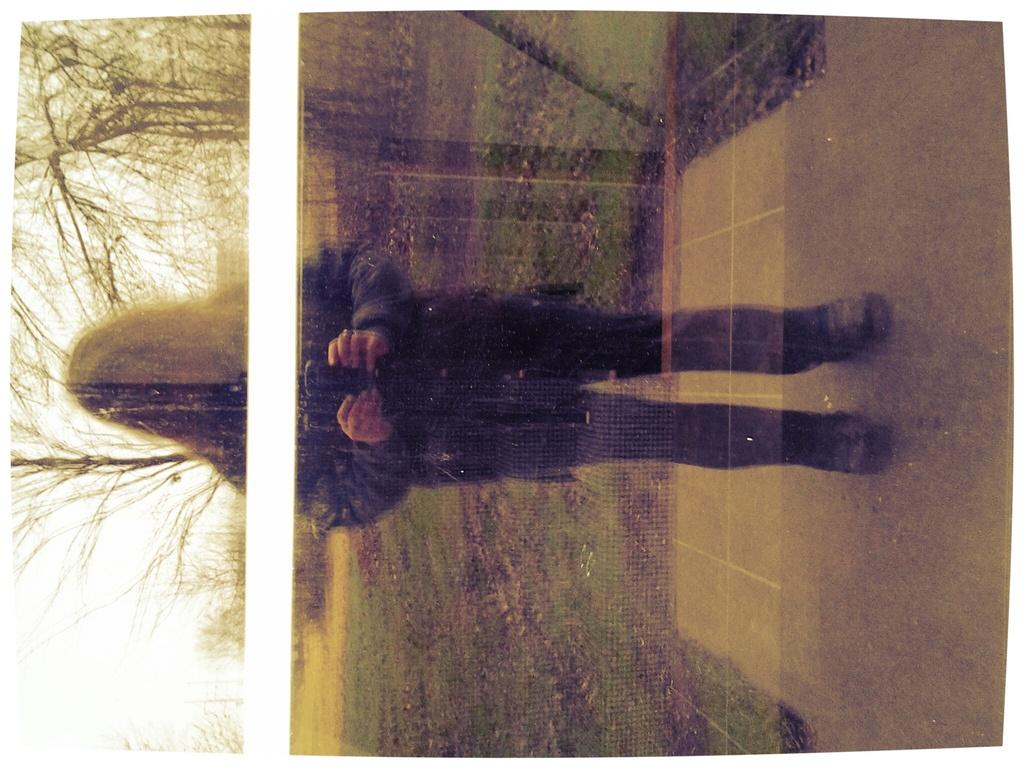How is the orientation of the image? The image is tilted. What can be seen in the foreground of the image? There is a lady standing in the image. What type of natural scenery is visible in the background of the image? There are trees in the background of the image. How is the background of the image depicted? The background is blurred. How does the beggar measure the throat of the lady in the image? There is no beggar or any indication of measuring a throat in the image. 